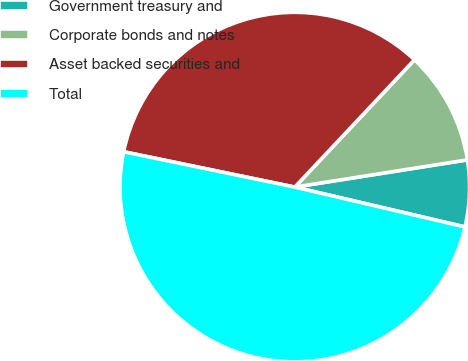Convert chart to OTSL. <chart><loc_0><loc_0><loc_500><loc_500><pie_chart><fcel>Government treasury and<fcel>Corporate bonds and notes<fcel>Asset backed securities and<fcel>Total<nl><fcel>6.15%<fcel>10.5%<fcel>33.77%<fcel>49.59%<nl></chart> 